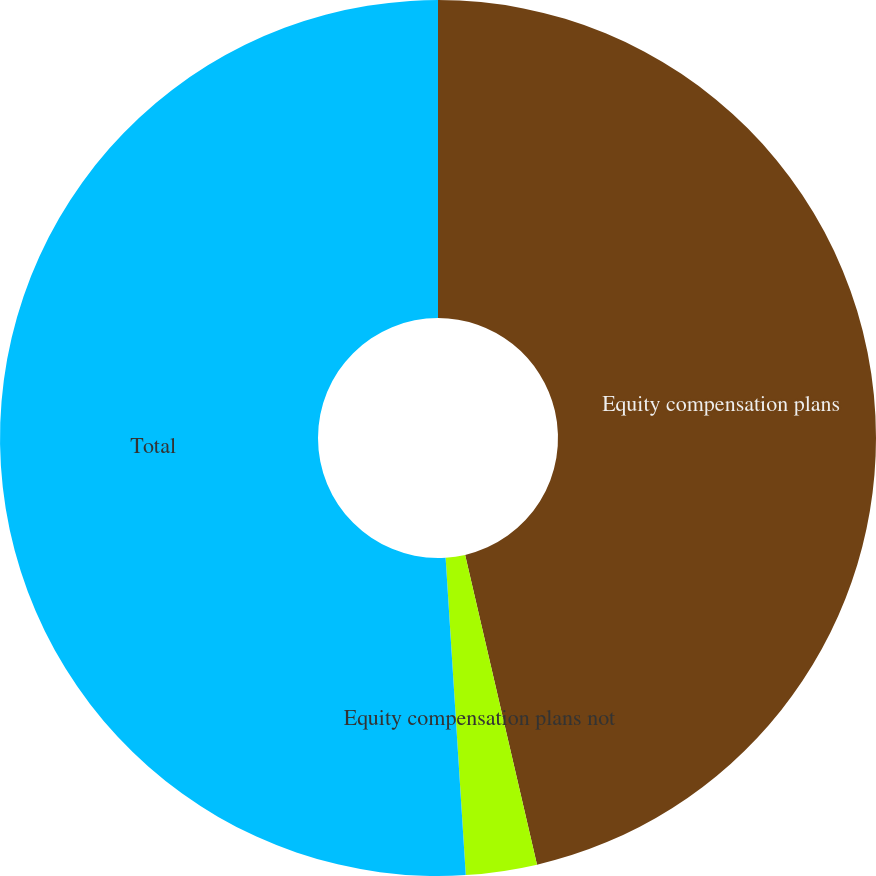<chart> <loc_0><loc_0><loc_500><loc_500><pie_chart><fcel>Equity compensation plans<fcel>Equity compensation plans not<fcel>Total<nl><fcel>46.37%<fcel>2.62%<fcel>51.01%<nl></chart> 